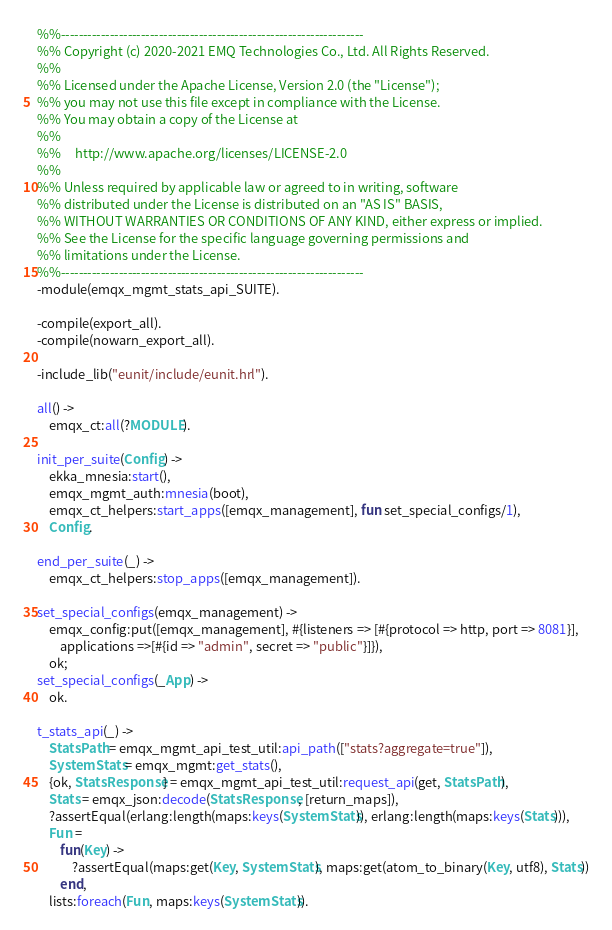<code> <loc_0><loc_0><loc_500><loc_500><_Erlang_>%%--------------------------------------------------------------------
%% Copyright (c) 2020-2021 EMQ Technologies Co., Ltd. All Rights Reserved.
%%
%% Licensed under the Apache License, Version 2.0 (the "License");
%% you may not use this file except in compliance with the License.
%% You may obtain a copy of the License at
%%
%%     http://www.apache.org/licenses/LICENSE-2.0
%%
%% Unless required by applicable law or agreed to in writing, software
%% distributed under the License is distributed on an "AS IS" BASIS,
%% WITHOUT WARRANTIES OR CONDITIONS OF ANY KIND, either express or implied.
%% See the License for the specific language governing permissions and
%% limitations under the License.
%%--------------------------------------------------------------------
-module(emqx_mgmt_stats_api_SUITE).

-compile(export_all).
-compile(nowarn_export_all).

-include_lib("eunit/include/eunit.hrl").

all() ->
    emqx_ct:all(?MODULE).

init_per_suite(Config) ->
    ekka_mnesia:start(),
    emqx_mgmt_auth:mnesia(boot),
    emqx_ct_helpers:start_apps([emqx_management], fun set_special_configs/1),
    Config.

end_per_suite(_) ->
    emqx_ct_helpers:stop_apps([emqx_management]).

set_special_configs(emqx_management) ->
    emqx_config:put([emqx_management], #{listeners => [#{protocol => http, port => 8081}],
        applications =>[#{id => "admin", secret => "public"}]}),
    ok;
set_special_configs(_App) ->
    ok.

t_stats_api(_) ->
    StatsPath = emqx_mgmt_api_test_util:api_path(["stats?aggregate=true"]),
    SystemStats = emqx_mgmt:get_stats(),
    {ok, StatsResponse} = emqx_mgmt_api_test_util:request_api(get, StatsPath),
    Stats = emqx_json:decode(StatsResponse, [return_maps]),
    ?assertEqual(erlang:length(maps:keys(SystemStats)), erlang:length(maps:keys(Stats))),
    Fun =
        fun(Key) ->
            ?assertEqual(maps:get(Key, SystemStats), maps:get(atom_to_binary(Key, utf8), Stats))
        end,
    lists:foreach(Fun, maps:keys(SystemStats)).
</code> 